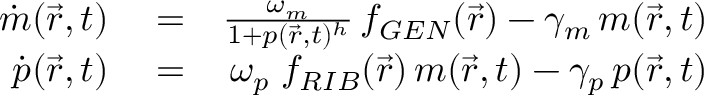<formula> <loc_0><loc_0><loc_500><loc_500>\begin{array} { r l r } { \dot { m } ( \vec { r } , t ) } & = } & { \frac { \omega _ { m } } { 1 + p ( \vec { r } , t ) ^ { h } } \, f _ { G E N } ( \vec { r } ) - \gamma _ { m } \, m ( \vec { r } , t ) } \\ { \dot { p } ( \vec { r } , t ) } & = } & { \omega _ { p } \, f _ { R I B } ( \vec { r } ) \, m ( \vec { r } , t ) - \gamma _ { p } \, p ( \vec { r } , t ) } \end{array}</formula> 